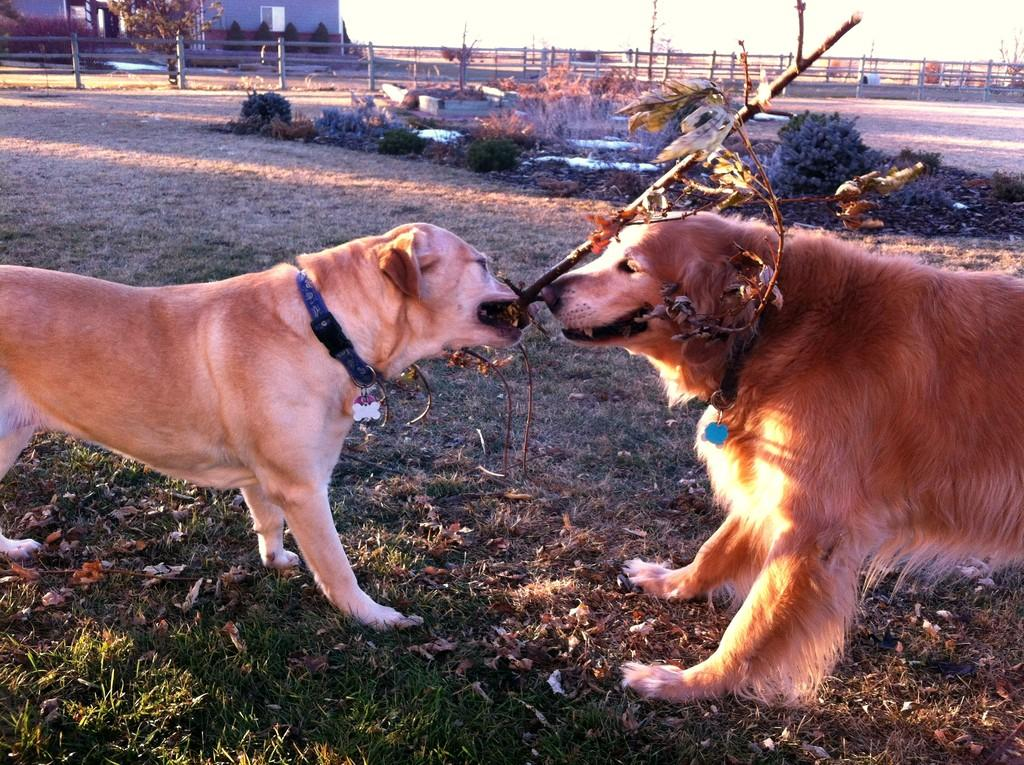How many dogs are in the image? There are two dogs in the image. What are the dogs doing in the image? The dogs are holding sticks in their mouths. What type of surface is visible at the bottom of the image? There is grass visible at the bottom of the image. What can be seen in the background of the image? There are plants, fencing, and a building in the background of the image. What type of finger can be seen in the image? There are no fingers present in the image; it features two dogs holding sticks in their mouths. What liquid is being poured from a container in the image? There is no liquid or container present in the image. 